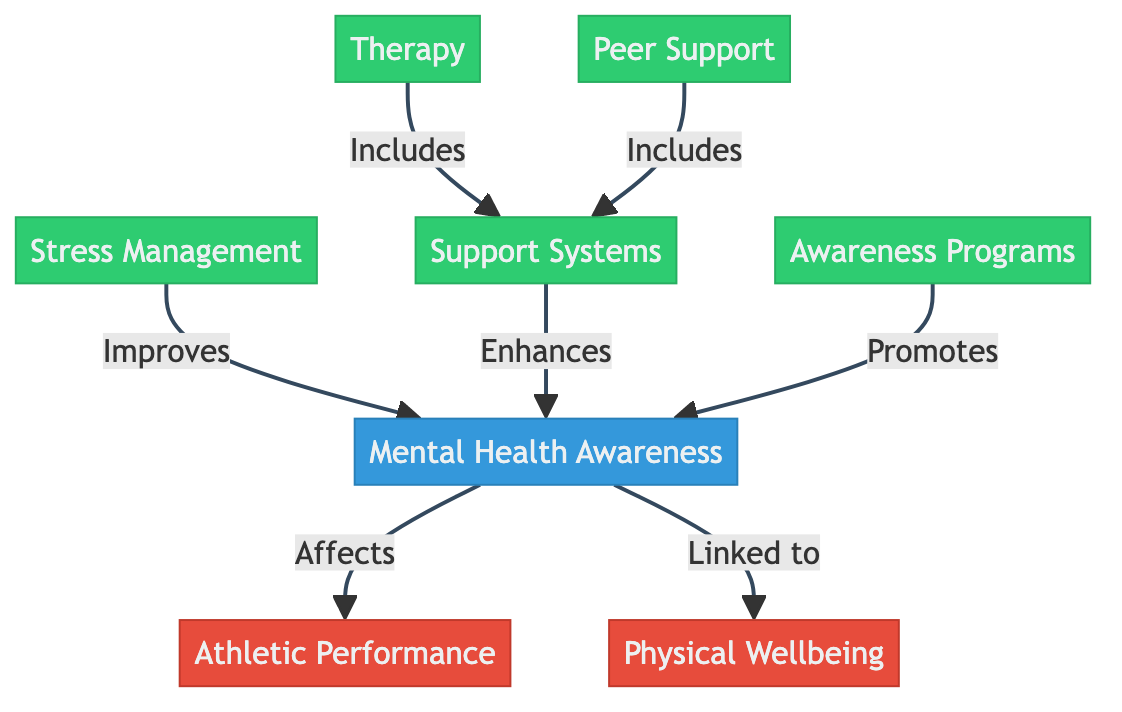What are the three main components of the diagram? The diagram highlights three main components: Mental Health Awareness, Athletic Performance, and Physical Wellbeing. These nodes are central and connected by relationships that showcase their interactions.
Answer: Mental Health Awareness, Athletic Performance, Physical Wellbeing How many secondary nodes are present in the diagram? The diagram includes one secondary node labeled Athletic Performance and one labeled Physical Wellbeing, totaling two secondary nodes.
Answer: 2 What does Stress Management improve according to the diagram? The diagram shows an arrow leading from Stress Management to Mental Health Awareness, indicating that Stress Management improves Mental Health Awareness.
Answer: Mental Health Awareness What relationship does Mental Health Awareness have with Athletic Performance? The connection from Mental Health Awareness to Athletic Performance indicates that Mental Health Awareness affects Athletic Performance positively.
Answer: Affects Which support is included in therapy? The diagram illustrates that Therapy includes Support Systems as a component, depicting how therapy can integrate external support for better mental health.
Answer: Support Systems What programs promote Mental Health Awareness? Awareness Programs are explicitly linked to Mental Health Awareness in the diagram, denoting that these programs play a crucial role in promoting awareness among athletes.
Answer: Awareness Programs What enhances Mental Health? The diagram shows Support Systems enhancing Mental Health, pointing out the importance of external support mechanisms in improving mental health outcomes for athletes.
Answer: Support Systems What is the inclusion relationship shown between Peer Support and Support Systems? The diagram depicts that Peer Support is included within Support Systems, highlighting its role as a specific type of support that contributes to mental health awareness and improvement.
Answer: Support Systems How does Mental Health relate to Physical Wellbeing? The diagram indicates that Mental Health is linked to Physical Wellbeing, suggesting that maintaining good mental health is essential for overall physical health and performance in athletes.
Answer: Linked to What factors contribute to Mental Health Awareness as shown in the diagram? Stress Management, Support Systems, and Awareness Programs are all factors leading to enhanced Mental Health Awareness, displaying the multi-faceted approach needed for mental well-being in athletes.
Answer: Stress Management, Support Systems, Awareness Programs 